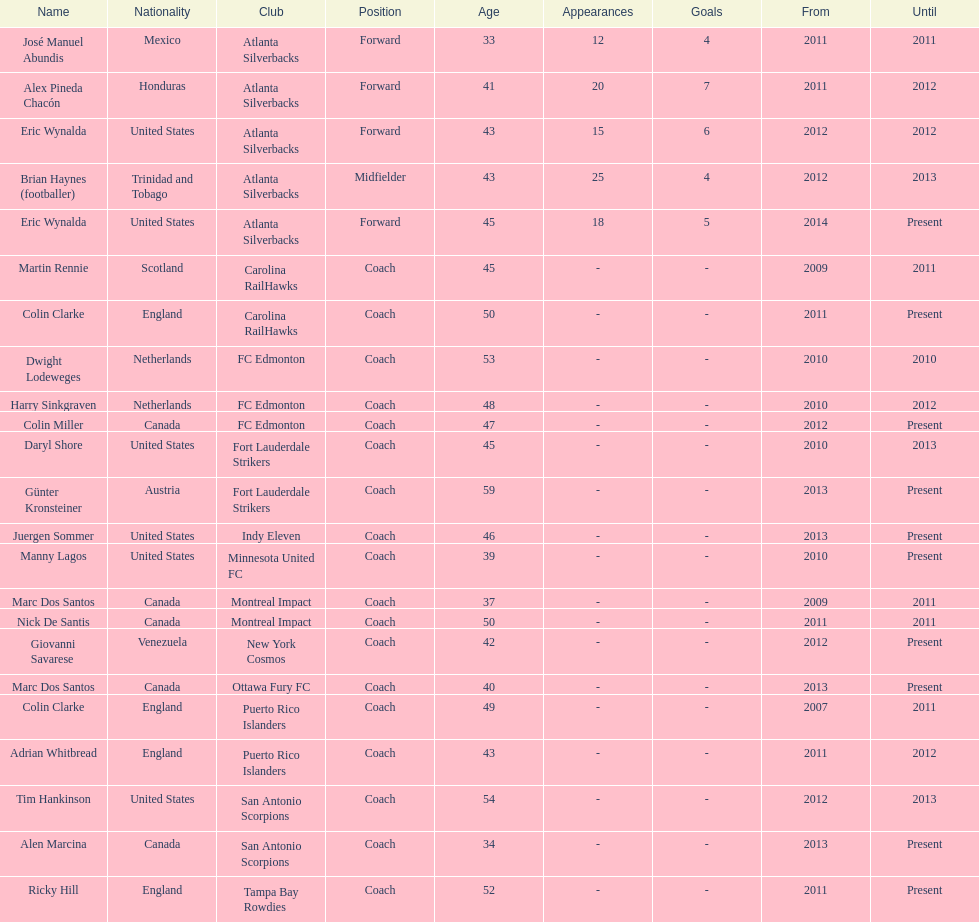How many total coaches on the list are from canada? 5. 